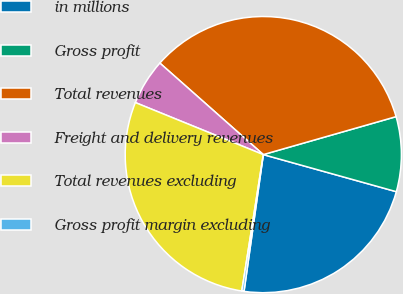Convert chart. <chart><loc_0><loc_0><loc_500><loc_500><pie_chart><fcel>in millions<fcel>Gross profit<fcel>Total revenues<fcel>Freight and delivery revenues<fcel>Total revenues excluding<fcel>Gross profit margin excluding<nl><fcel>22.9%<fcel>8.76%<fcel>34.04%<fcel>5.38%<fcel>28.66%<fcel>0.26%<nl></chart> 